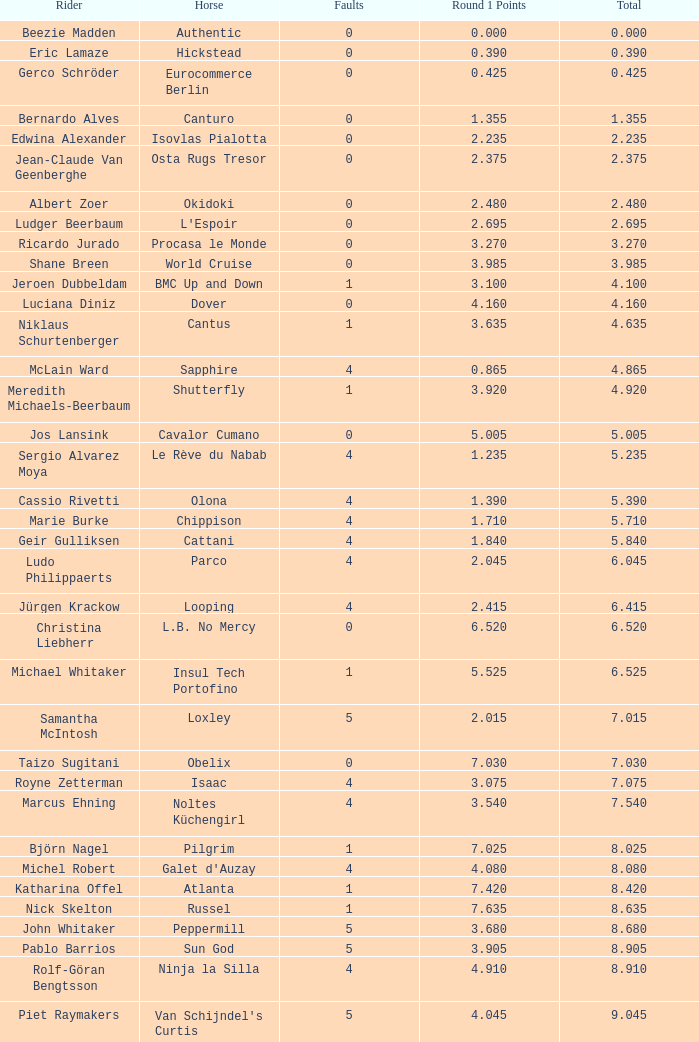What is the highest total for carlson's horse? 29.545. 